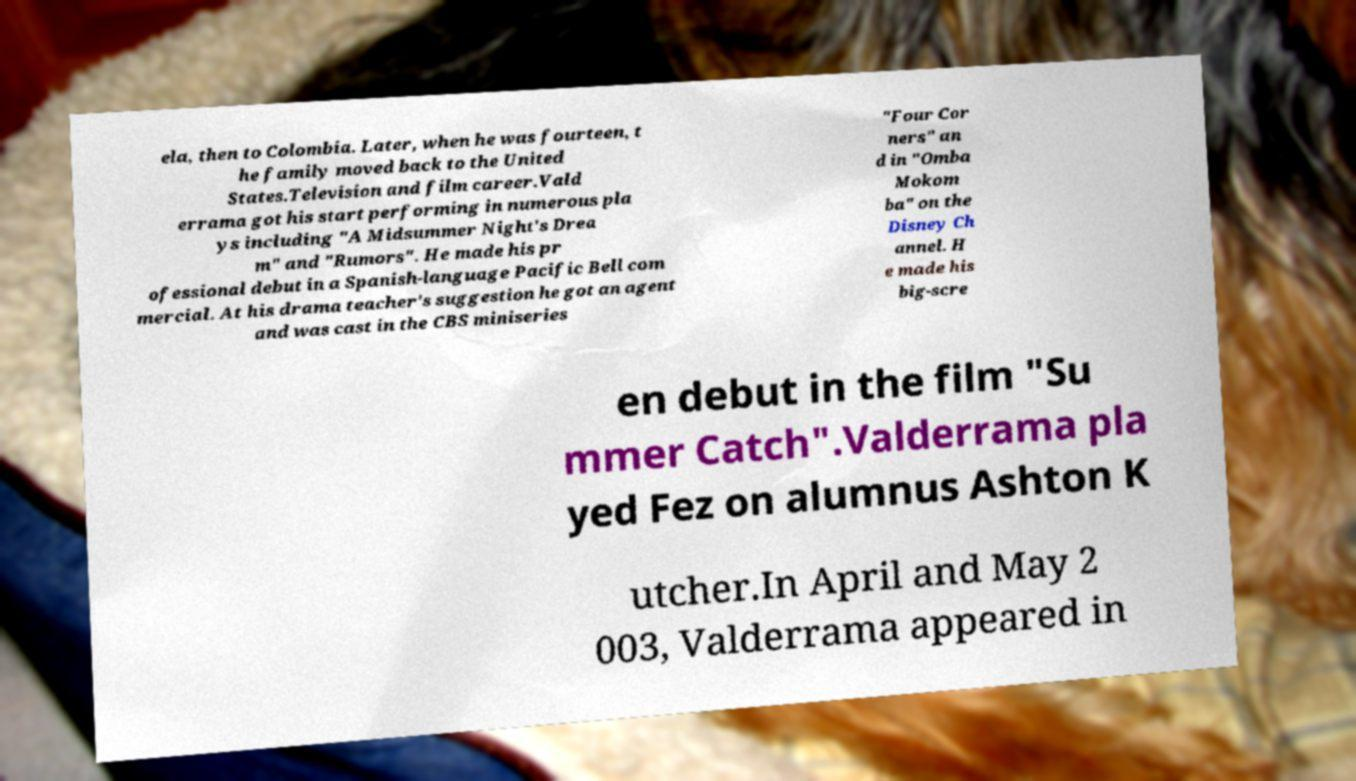Can you read and provide the text displayed in the image?This photo seems to have some interesting text. Can you extract and type it out for me? ela, then to Colombia. Later, when he was fourteen, t he family moved back to the United States.Television and film career.Vald errama got his start performing in numerous pla ys including "A Midsummer Night's Drea m" and "Rumors". He made his pr ofessional debut in a Spanish-language Pacific Bell com mercial. At his drama teacher's suggestion he got an agent and was cast in the CBS miniseries "Four Cor ners" an d in "Omba Mokom ba" on the Disney Ch annel. H e made his big-scre en debut in the film "Su mmer Catch".Valderrama pla yed Fez on alumnus Ashton K utcher.In April and May 2 003, Valderrama appeared in 